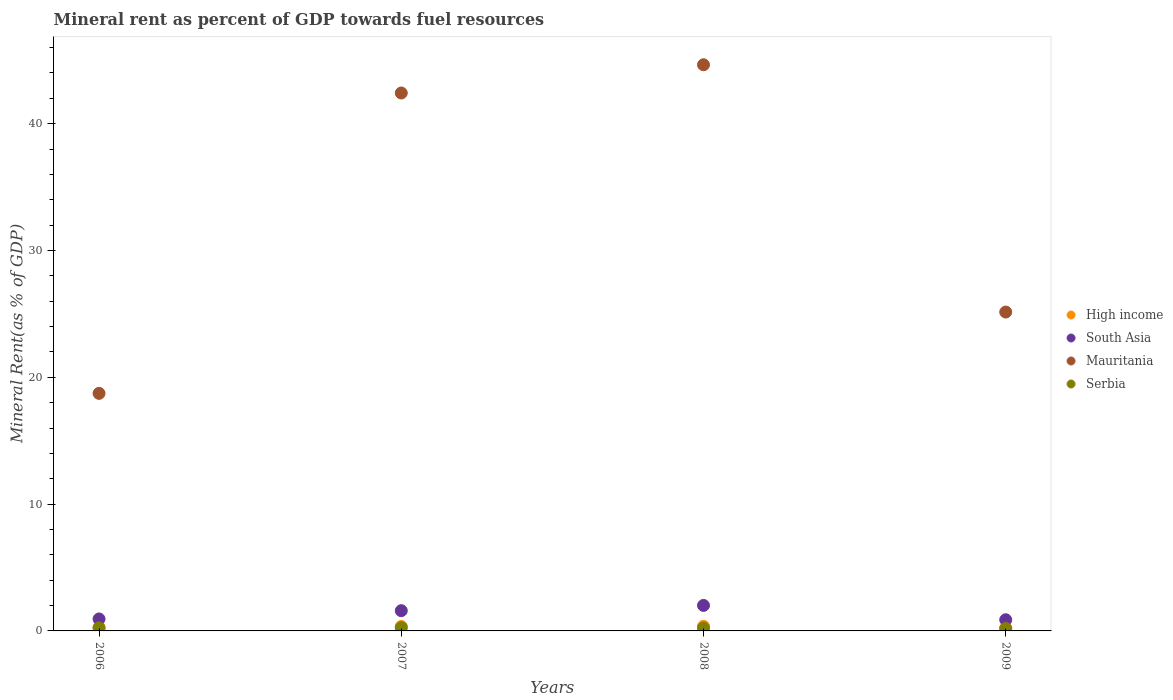How many different coloured dotlines are there?
Provide a succinct answer. 4. Is the number of dotlines equal to the number of legend labels?
Your response must be concise. Yes. What is the mineral rent in Serbia in 2008?
Your answer should be very brief. 0.23. Across all years, what is the maximum mineral rent in High income?
Your answer should be compact. 0.36. Across all years, what is the minimum mineral rent in Mauritania?
Your answer should be very brief. 18.73. What is the total mineral rent in Serbia in the graph?
Give a very brief answer. 0.91. What is the difference between the mineral rent in South Asia in 2006 and that in 2007?
Offer a very short reply. -0.65. What is the difference between the mineral rent in High income in 2008 and the mineral rent in South Asia in 2007?
Provide a succinct answer. -1.23. What is the average mineral rent in South Asia per year?
Your answer should be very brief. 1.36. In the year 2009, what is the difference between the mineral rent in South Asia and mineral rent in Serbia?
Keep it short and to the point. 0.69. In how many years, is the mineral rent in High income greater than 24 %?
Offer a very short reply. 0. What is the ratio of the mineral rent in High income in 2007 to that in 2009?
Keep it short and to the point. 1.54. Is the mineral rent in High income in 2007 less than that in 2008?
Your answer should be compact. Yes. What is the difference between the highest and the second highest mineral rent in South Asia?
Make the answer very short. 0.42. What is the difference between the highest and the lowest mineral rent in Serbia?
Make the answer very short. 0.07. In how many years, is the mineral rent in Mauritania greater than the average mineral rent in Mauritania taken over all years?
Your response must be concise. 2. Is it the case that in every year, the sum of the mineral rent in High income and mineral rent in Serbia  is greater than the mineral rent in Mauritania?
Provide a succinct answer. No. How many dotlines are there?
Ensure brevity in your answer.  4. What is the difference between two consecutive major ticks on the Y-axis?
Provide a succinct answer. 10. Does the graph contain any zero values?
Provide a short and direct response. No. Does the graph contain grids?
Your answer should be very brief. No. How are the legend labels stacked?
Provide a short and direct response. Vertical. What is the title of the graph?
Your response must be concise. Mineral rent as percent of GDP towards fuel resources. What is the label or title of the X-axis?
Give a very brief answer. Years. What is the label or title of the Y-axis?
Provide a short and direct response. Mineral Rent(as % of GDP). What is the Mineral Rent(as % of GDP) in High income in 2006?
Provide a succinct answer. 0.27. What is the Mineral Rent(as % of GDP) of South Asia in 2006?
Provide a short and direct response. 0.94. What is the Mineral Rent(as % of GDP) in Mauritania in 2006?
Offer a terse response. 18.73. What is the Mineral Rent(as % of GDP) of Serbia in 2006?
Keep it short and to the point. 0.24. What is the Mineral Rent(as % of GDP) in High income in 2007?
Your answer should be very brief. 0.35. What is the Mineral Rent(as % of GDP) of South Asia in 2007?
Keep it short and to the point. 1.6. What is the Mineral Rent(as % of GDP) of Mauritania in 2007?
Provide a succinct answer. 42.42. What is the Mineral Rent(as % of GDP) in Serbia in 2007?
Ensure brevity in your answer.  0.26. What is the Mineral Rent(as % of GDP) of High income in 2008?
Offer a terse response. 0.36. What is the Mineral Rent(as % of GDP) in South Asia in 2008?
Give a very brief answer. 2.01. What is the Mineral Rent(as % of GDP) of Mauritania in 2008?
Offer a very short reply. 44.64. What is the Mineral Rent(as % of GDP) in Serbia in 2008?
Your answer should be very brief. 0.23. What is the Mineral Rent(as % of GDP) in High income in 2009?
Provide a succinct answer. 0.23. What is the Mineral Rent(as % of GDP) of South Asia in 2009?
Make the answer very short. 0.88. What is the Mineral Rent(as % of GDP) in Mauritania in 2009?
Offer a terse response. 25.14. What is the Mineral Rent(as % of GDP) in Serbia in 2009?
Ensure brevity in your answer.  0.19. Across all years, what is the maximum Mineral Rent(as % of GDP) of High income?
Offer a terse response. 0.36. Across all years, what is the maximum Mineral Rent(as % of GDP) of South Asia?
Your answer should be very brief. 2.01. Across all years, what is the maximum Mineral Rent(as % of GDP) of Mauritania?
Ensure brevity in your answer.  44.64. Across all years, what is the maximum Mineral Rent(as % of GDP) of Serbia?
Your answer should be compact. 0.26. Across all years, what is the minimum Mineral Rent(as % of GDP) in High income?
Ensure brevity in your answer.  0.23. Across all years, what is the minimum Mineral Rent(as % of GDP) of South Asia?
Your answer should be very brief. 0.88. Across all years, what is the minimum Mineral Rent(as % of GDP) in Mauritania?
Offer a terse response. 18.73. Across all years, what is the minimum Mineral Rent(as % of GDP) in Serbia?
Offer a terse response. 0.19. What is the total Mineral Rent(as % of GDP) of High income in the graph?
Provide a succinct answer. 1.21. What is the total Mineral Rent(as % of GDP) of South Asia in the graph?
Keep it short and to the point. 5.43. What is the total Mineral Rent(as % of GDP) of Mauritania in the graph?
Keep it short and to the point. 130.94. What is the total Mineral Rent(as % of GDP) of Serbia in the graph?
Give a very brief answer. 0.91. What is the difference between the Mineral Rent(as % of GDP) in High income in 2006 and that in 2007?
Ensure brevity in your answer.  -0.08. What is the difference between the Mineral Rent(as % of GDP) of South Asia in 2006 and that in 2007?
Offer a very short reply. -0.65. What is the difference between the Mineral Rent(as % of GDP) in Mauritania in 2006 and that in 2007?
Your answer should be compact. -23.69. What is the difference between the Mineral Rent(as % of GDP) in Serbia in 2006 and that in 2007?
Your answer should be very brief. -0.02. What is the difference between the Mineral Rent(as % of GDP) of High income in 2006 and that in 2008?
Ensure brevity in your answer.  -0.1. What is the difference between the Mineral Rent(as % of GDP) of South Asia in 2006 and that in 2008?
Your answer should be compact. -1.07. What is the difference between the Mineral Rent(as % of GDP) in Mauritania in 2006 and that in 2008?
Offer a very short reply. -25.91. What is the difference between the Mineral Rent(as % of GDP) of Serbia in 2006 and that in 2008?
Make the answer very short. 0.01. What is the difference between the Mineral Rent(as % of GDP) in High income in 2006 and that in 2009?
Give a very brief answer. 0.04. What is the difference between the Mineral Rent(as % of GDP) of South Asia in 2006 and that in 2009?
Make the answer very short. 0.06. What is the difference between the Mineral Rent(as % of GDP) of Mauritania in 2006 and that in 2009?
Give a very brief answer. -6.41. What is the difference between the Mineral Rent(as % of GDP) in Serbia in 2006 and that in 2009?
Your response must be concise. 0.05. What is the difference between the Mineral Rent(as % of GDP) in High income in 2007 and that in 2008?
Your response must be concise. -0.01. What is the difference between the Mineral Rent(as % of GDP) of South Asia in 2007 and that in 2008?
Offer a very short reply. -0.42. What is the difference between the Mineral Rent(as % of GDP) of Mauritania in 2007 and that in 2008?
Offer a very short reply. -2.23. What is the difference between the Mineral Rent(as % of GDP) of Serbia in 2007 and that in 2008?
Ensure brevity in your answer.  0.02. What is the difference between the Mineral Rent(as % of GDP) of High income in 2007 and that in 2009?
Keep it short and to the point. 0.12. What is the difference between the Mineral Rent(as % of GDP) of South Asia in 2007 and that in 2009?
Provide a succinct answer. 0.72. What is the difference between the Mineral Rent(as % of GDP) in Mauritania in 2007 and that in 2009?
Make the answer very short. 17.27. What is the difference between the Mineral Rent(as % of GDP) of Serbia in 2007 and that in 2009?
Ensure brevity in your answer.  0.07. What is the difference between the Mineral Rent(as % of GDP) of High income in 2008 and that in 2009?
Your answer should be compact. 0.14. What is the difference between the Mineral Rent(as % of GDP) in South Asia in 2008 and that in 2009?
Give a very brief answer. 1.13. What is the difference between the Mineral Rent(as % of GDP) in Mauritania in 2008 and that in 2009?
Offer a terse response. 19.5. What is the difference between the Mineral Rent(as % of GDP) in Serbia in 2008 and that in 2009?
Ensure brevity in your answer.  0.04. What is the difference between the Mineral Rent(as % of GDP) of High income in 2006 and the Mineral Rent(as % of GDP) of South Asia in 2007?
Provide a succinct answer. -1.33. What is the difference between the Mineral Rent(as % of GDP) of High income in 2006 and the Mineral Rent(as % of GDP) of Mauritania in 2007?
Give a very brief answer. -42.15. What is the difference between the Mineral Rent(as % of GDP) of High income in 2006 and the Mineral Rent(as % of GDP) of Serbia in 2007?
Offer a very short reply. 0.01. What is the difference between the Mineral Rent(as % of GDP) of South Asia in 2006 and the Mineral Rent(as % of GDP) of Mauritania in 2007?
Keep it short and to the point. -41.47. What is the difference between the Mineral Rent(as % of GDP) of South Asia in 2006 and the Mineral Rent(as % of GDP) of Serbia in 2007?
Your answer should be compact. 0.69. What is the difference between the Mineral Rent(as % of GDP) in Mauritania in 2006 and the Mineral Rent(as % of GDP) in Serbia in 2007?
Keep it short and to the point. 18.48. What is the difference between the Mineral Rent(as % of GDP) of High income in 2006 and the Mineral Rent(as % of GDP) of South Asia in 2008?
Your answer should be compact. -1.75. What is the difference between the Mineral Rent(as % of GDP) of High income in 2006 and the Mineral Rent(as % of GDP) of Mauritania in 2008?
Keep it short and to the point. -44.38. What is the difference between the Mineral Rent(as % of GDP) of High income in 2006 and the Mineral Rent(as % of GDP) of Serbia in 2008?
Offer a terse response. 0.03. What is the difference between the Mineral Rent(as % of GDP) in South Asia in 2006 and the Mineral Rent(as % of GDP) in Mauritania in 2008?
Provide a succinct answer. -43.7. What is the difference between the Mineral Rent(as % of GDP) in South Asia in 2006 and the Mineral Rent(as % of GDP) in Serbia in 2008?
Offer a very short reply. 0.71. What is the difference between the Mineral Rent(as % of GDP) in Mauritania in 2006 and the Mineral Rent(as % of GDP) in Serbia in 2008?
Give a very brief answer. 18.5. What is the difference between the Mineral Rent(as % of GDP) of High income in 2006 and the Mineral Rent(as % of GDP) of South Asia in 2009?
Ensure brevity in your answer.  -0.61. What is the difference between the Mineral Rent(as % of GDP) of High income in 2006 and the Mineral Rent(as % of GDP) of Mauritania in 2009?
Your answer should be compact. -24.88. What is the difference between the Mineral Rent(as % of GDP) of High income in 2006 and the Mineral Rent(as % of GDP) of Serbia in 2009?
Your answer should be compact. 0.08. What is the difference between the Mineral Rent(as % of GDP) in South Asia in 2006 and the Mineral Rent(as % of GDP) in Mauritania in 2009?
Your response must be concise. -24.2. What is the difference between the Mineral Rent(as % of GDP) in South Asia in 2006 and the Mineral Rent(as % of GDP) in Serbia in 2009?
Provide a short and direct response. 0.76. What is the difference between the Mineral Rent(as % of GDP) in Mauritania in 2006 and the Mineral Rent(as % of GDP) in Serbia in 2009?
Provide a succinct answer. 18.55. What is the difference between the Mineral Rent(as % of GDP) in High income in 2007 and the Mineral Rent(as % of GDP) in South Asia in 2008?
Your answer should be very brief. -1.66. What is the difference between the Mineral Rent(as % of GDP) in High income in 2007 and the Mineral Rent(as % of GDP) in Mauritania in 2008?
Offer a very short reply. -44.29. What is the difference between the Mineral Rent(as % of GDP) of High income in 2007 and the Mineral Rent(as % of GDP) of Serbia in 2008?
Keep it short and to the point. 0.12. What is the difference between the Mineral Rent(as % of GDP) in South Asia in 2007 and the Mineral Rent(as % of GDP) in Mauritania in 2008?
Your response must be concise. -43.05. What is the difference between the Mineral Rent(as % of GDP) in South Asia in 2007 and the Mineral Rent(as % of GDP) in Serbia in 2008?
Ensure brevity in your answer.  1.36. What is the difference between the Mineral Rent(as % of GDP) in Mauritania in 2007 and the Mineral Rent(as % of GDP) in Serbia in 2008?
Provide a short and direct response. 42.19. What is the difference between the Mineral Rent(as % of GDP) of High income in 2007 and the Mineral Rent(as % of GDP) of South Asia in 2009?
Offer a terse response. -0.53. What is the difference between the Mineral Rent(as % of GDP) of High income in 2007 and the Mineral Rent(as % of GDP) of Mauritania in 2009?
Make the answer very short. -24.79. What is the difference between the Mineral Rent(as % of GDP) in High income in 2007 and the Mineral Rent(as % of GDP) in Serbia in 2009?
Provide a short and direct response. 0.16. What is the difference between the Mineral Rent(as % of GDP) in South Asia in 2007 and the Mineral Rent(as % of GDP) in Mauritania in 2009?
Offer a very short reply. -23.55. What is the difference between the Mineral Rent(as % of GDP) of South Asia in 2007 and the Mineral Rent(as % of GDP) of Serbia in 2009?
Ensure brevity in your answer.  1.41. What is the difference between the Mineral Rent(as % of GDP) of Mauritania in 2007 and the Mineral Rent(as % of GDP) of Serbia in 2009?
Your response must be concise. 42.23. What is the difference between the Mineral Rent(as % of GDP) of High income in 2008 and the Mineral Rent(as % of GDP) of South Asia in 2009?
Keep it short and to the point. -0.52. What is the difference between the Mineral Rent(as % of GDP) in High income in 2008 and the Mineral Rent(as % of GDP) in Mauritania in 2009?
Offer a terse response. -24.78. What is the difference between the Mineral Rent(as % of GDP) in High income in 2008 and the Mineral Rent(as % of GDP) in Serbia in 2009?
Give a very brief answer. 0.18. What is the difference between the Mineral Rent(as % of GDP) of South Asia in 2008 and the Mineral Rent(as % of GDP) of Mauritania in 2009?
Your answer should be very brief. -23.13. What is the difference between the Mineral Rent(as % of GDP) in South Asia in 2008 and the Mineral Rent(as % of GDP) in Serbia in 2009?
Your answer should be compact. 1.82. What is the difference between the Mineral Rent(as % of GDP) of Mauritania in 2008 and the Mineral Rent(as % of GDP) of Serbia in 2009?
Provide a succinct answer. 44.46. What is the average Mineral Rent(as % of GDP) of High income per year?
Ensure brevity in your answer.  0.3. What is the average Mineral Rent(as % of GDP) of South Asia per year?
Offer a terse response. 1.36. What is the average Mineral Rent(as % of GDP) in Mauritania per year?
Keep it short and to the point. 32.73. What is the average Mineral Rent(as % of GDP) in Serbia per year?
Provide a succinct answer. 0.23. In the year 2006, what is the difference between the Mineral Rent(as % of GDP) in High income and Mineral Rent(as % of GDP) in South Asia?
Your response must be concise. -0.68. In the year 2006, what is the difference between the Mineral Rent(as % of GDP) of High income and Mineral Rent(as % of GDP) of Mauritania?
Provide a succinct answer. -18.47. In the year 2006, what is the difference between the Mineral Rent(as % of GDP) of High income and Mineral Rent(as % of GDP) of Serbia?
Your answer should be compact. 0.03. In the year 2006, what is the difference between the Mineral Rent(as % of GDP) of South Asia and Mineral Rent(as % of GDP) of Mauritania?
Offer a very short reply. -17.79. In the year 2006, what is the difference between the Mineral Rent(as % of GDP) of South Asia and Mineral Rent(as % of GDP) of Serbia?
Ensure brevity in your answer.  0.71. In the year 2006, what is the difference between the Mineral Rent(as % of GDP) in Mauritania and Mineral Rent(as % of GDP) in Serbia?
Provide a succinct answer. 18.5. In the year 2007, what is the difference between the Mineral Rent(as % of GDP) in High income and Mineral Rent(as % of GDP) in South Asia?
Your answer should be compact. -1.25. In the year 2007, what is the difference between the Mineral Rent(as % of GDP) in High income and Mineral Rent(as % of GDP) in Mauritania?
Ensure brevity in your answer.  -42.07. In the year 2007, what is the difference between the Mineral Rent(as % of GDP) in High income and Mineral Rent(as % of GDP) in Serbia?
Provide a short and direct response. 0.09. In the year 2007, what is the difference between the Mineral Rent(as % of GDP) of South Asia and Mineral Rent(as % of GDP) of Mauritania?
Your response must be concise. -40.82. In the year 2007, what is the difference between the Mineral Rent(as % of GDP) in South Asia and Mineral Rent(as % of GDP) in Serbia?
Your answer should be compact. 1.34. In the year 2007, what is the difference between the Mineral Rent(as % of GDP) in Mauritania and Mineral Rent(as % of GDP) in Serbia?
Your answer should be compact. 42.16. In the year 2008, what is the difference between the Mineral Rent(as % of GDP) of High income and Mineral Rent(as % of GDP) of South Asia?
Offer a terse response. -1.65. In the year 2008, what is the difference between the Mineral Rent(as % of GDP) in High income and Mineral Rent(as % of GDP) in Mauritania?
Your response must be concise. -44.28. In the year 2008, what is the difference between the Mineral Rent(as % of GDP) in High income and Mineral Rent(as % of GDP) in Serbia?
Keep it short and to the point. 0.13. In the year 2008, what is the difference between the Mineral Rent(as % of GDP) of South Asia and Mineral Rent(as % of GDP) of Mauritania?
Ensure brevity in your answer.  -42.63. In the year 2008, what is the difference between the Mineral Rent(as % of GDP) in South Asia and Mineral Rent(as % of GDP) in Serbia?
Offer a terse response. 1.78. In the year 2008, what is the difference between the Mineral Rent(as % of GDP) of Mauritania and Mineral Rent(as % of GDP) of Serbia?
Your answer should be very brief. 44.41. In the year 2009, what is the difference between the Mineral Rent(as % of GDP) in High income and Mineral Rent(as % of GDP) in South Asia?
Your answer should be very brief. -0.65. In the year 2009, what is the difference between the Mineral Rent(as % of GDP) of High income and Mineral Rent(as % of GDP) of Mauritania?
Make the answer very short. -24.92. In the year 2009, what is the difference between the Mineral Rent(as % of GDP) of South Asia and Mineral Rent(as % of GDP) of Mauritania?
Provide a succinct answer. -24.26. In the year 2009, what is the difference between the Mineral Rent(as % of GDP) of South Asia and Mineral Rent(as % of GDP) of Serbia?
Provide a succinct answer. 0.69. In the year 2009, what is the difference between the Mineral Rent(as % of GDP) in Mauritania and Mineral Rent(as % of GDP) in Serbia?
Your response must be concise. 24.96. What is the ratio of the Mineral Rent(as % of GDP) of High income in 2006 to that in 2007?
Provide a short and direct response. 0.76. What is the ratio of the Mineral Rent(as % of GDP) in South Asia in 2006 to that in 2007?
Make the answer very short. 0.59. What is the ratio of the Mineral Rent(as % of GDP) in Mauritania in 2006 to that in 2007?
Make the answer very short. 0.44. What is the ratio of the Mineral Rent(as % of GDP) of High income in 2006 to that in 2008?
Offer a terse response. 0.73. What is the ratio of the Mineral Rent(as % of GDP) in South Asia in 2006 to that in 2008?
Give a very brief answer. 0.47. What is the ratio of the Mineral Rent(as % of GDP) in Mauritania in 2006 to that in 2008?
Your response must be concise. 0.42. What is the ratio of the Mineral Rent(as % of GDP) in Serbia in 2006 to that in 2008?
Keep it short and to the point. 1.02. What is the ratio of the Mineral Rent(as % of GDP) of High income in 2006 to that in 2009?
Your answer should be compact. 1.17. What is the ratio of the Mineral Rent(as % of GDP) of South Asia in 2006 to that in 2009?
Offer a very short reply. 1.07. What is the ratio of the Mineral Rent(as % of GDP) in Mauritania in 2006 to that in 2009?
Your response must be concise. 0.74. What is the ratio of the Mineral Rent(as % of GDP) of Serbia in 2006 to that in 2009?
Provide a short and direct response. 1.27. What is the ratio of the Mineral Rent(as % of GDP) of High income in 2007 to that in 2008?
Ensure brevity in your answer.  0.96. What is the ratio of the Mineral Rent(as % of GDP) of South Asia in 2007 to that in 2008?
Ensure brevity in your answer.  0.79. What is the ratio of the Mineral Rent(as % of GDP) in Mauritania in 2007 to that in 2008?
Make the answer very short. 0.95. What is the ratio of the Mineral Rent(as % of GDP) in Serbia in 2007 to that in 2008?
Your answer should be compact. 1.1. What is the ratio of the Mineral Rent(as % of GDP) of High income in 2007 to that in 2009?
Provide a succinct answer. 1.54. What is the ratio of the Mineral Rent(as % of GDP) of South Asia in 2007 to that in 2009?
Your answer should be compact. 1.81. What is the ratio of the Mineral Rent(as % of GDP) of Mauritania in 2007 to that in 2009?
Provide a succinct answer. 1.69. What is the ratio of the Mineral Rent(as % of GDP) in Serbia in 2007 to that in 2009?
Offer a terse response. 1.37. What is the ratio of the Mineral Rent(as % of GDP) of High income in 2008 to that in 2009?
Your answer should be very brief. 1.6. What is the ratio of the Mineral Rent(as % of GDP) in South Asia in 2008 to that in 2009?
Give a very brief answer. 2.28. What is the ratio of the Mineral Rent(as % of GDP) of Mauritania in 2008 to that in 2009?
Give a very brief answer. 1.78. What is the ratio of the Mineral Rent(as % of GDP) of Serbia in 2008 to that in 2009?
Provide a succinct answer. 1.24. What is the difference between the highest and the second highest Mineral Rent(as % of GDP) in High income?
Keep it short and to the point. 0.01. What is the difference between the highest and the second highest Mineral Rent(as % of GDP) in South Asia?
Offer a very short reply. 0.42. What is the difference between the highest and the second highest Mineral Rent(as % of GDP) in Mauritania?
Ensure brevity in your answer.  2.23. What is the difference between the highest and the second highest Mineral Rent(as % of GDP) of Serbia?
Provide a short and direct response. 0.02. What is the difference between the highest and the lowest Mineral Rent(as % of GDP) in High income?
Your answer should be compact. 0.14. What is the difference between the highest and the lowest Mineral Rent(as % of GDP) in South Asia?
Your response must be concise. 1.13. What is the difference between the highest and the lowest Mineral Rent(as % of GDP) of Mauritania?
Provide a succinct answer. 25.91. What is the difference between the highest and the lowest Mineral Rent(as % of GDP) of Serbia?
Your answer should be very brief. 0.07. 